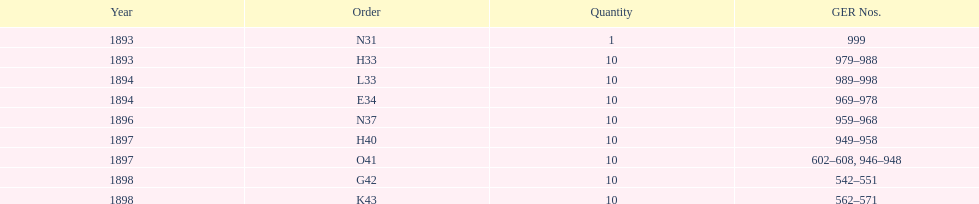Which year between 1893 and 1898 was there not an order? 1895. 